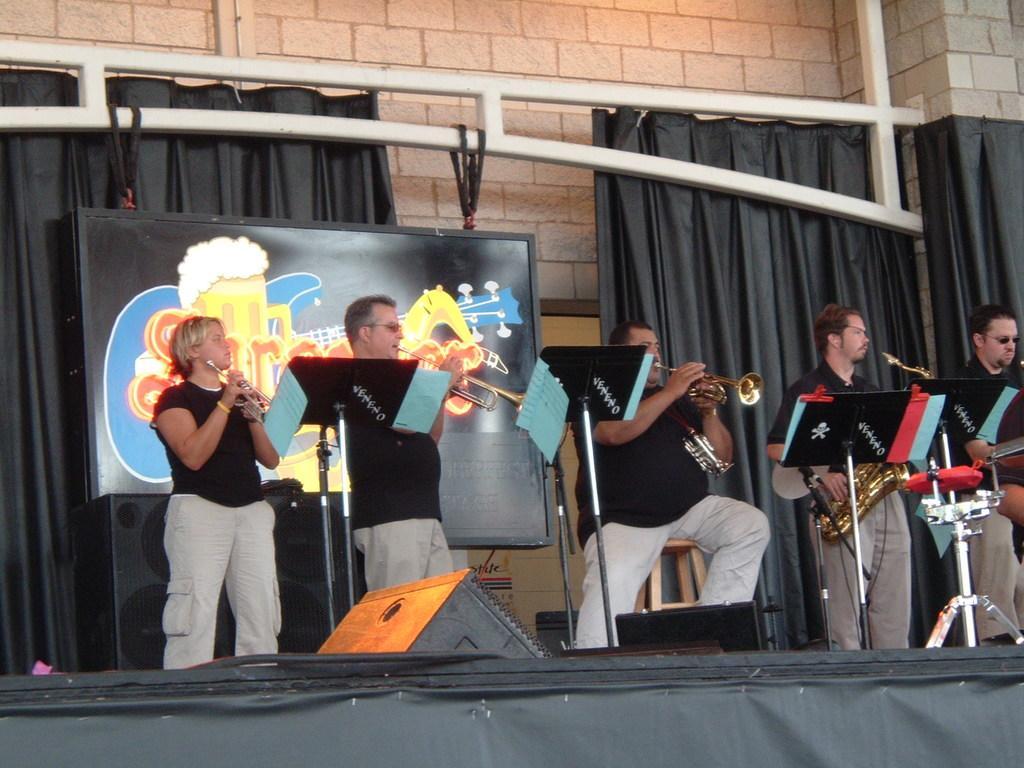Could you give a brief overview of what you see in this image? In the image there are a group of people standing on the stage, they are playing musical instruments and in front of them there are some music notations on the tables, behind them there is some board and behind that board there are black curtains, in the background there is a wall. 